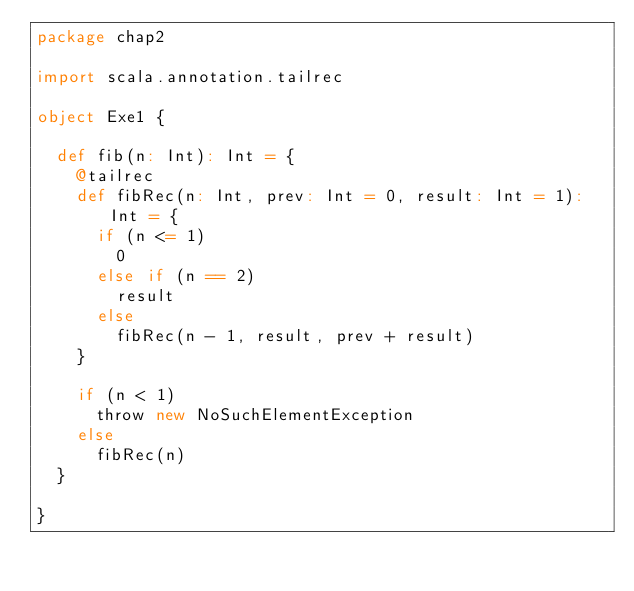Convert code to text. <code><loc_0><loc_0><loc_500><loc_500><_Scala_>package chap2

import scala.annotation.tailrec

object Exe1 {

  def fib(n: Int): Int = {
    @tailrec
    def fibRec(n: Int, prev: Int = 0, result: Int = 1): Int = {
      if (n <= 1)
        0
      else if (n == 2)
        result
      else
        fibRec(n - 1, result, prev + result)
    }

    if (n < 1)
      throw new NoSuchElementException
    else
      fibRec(n)
  }

}

</code> 